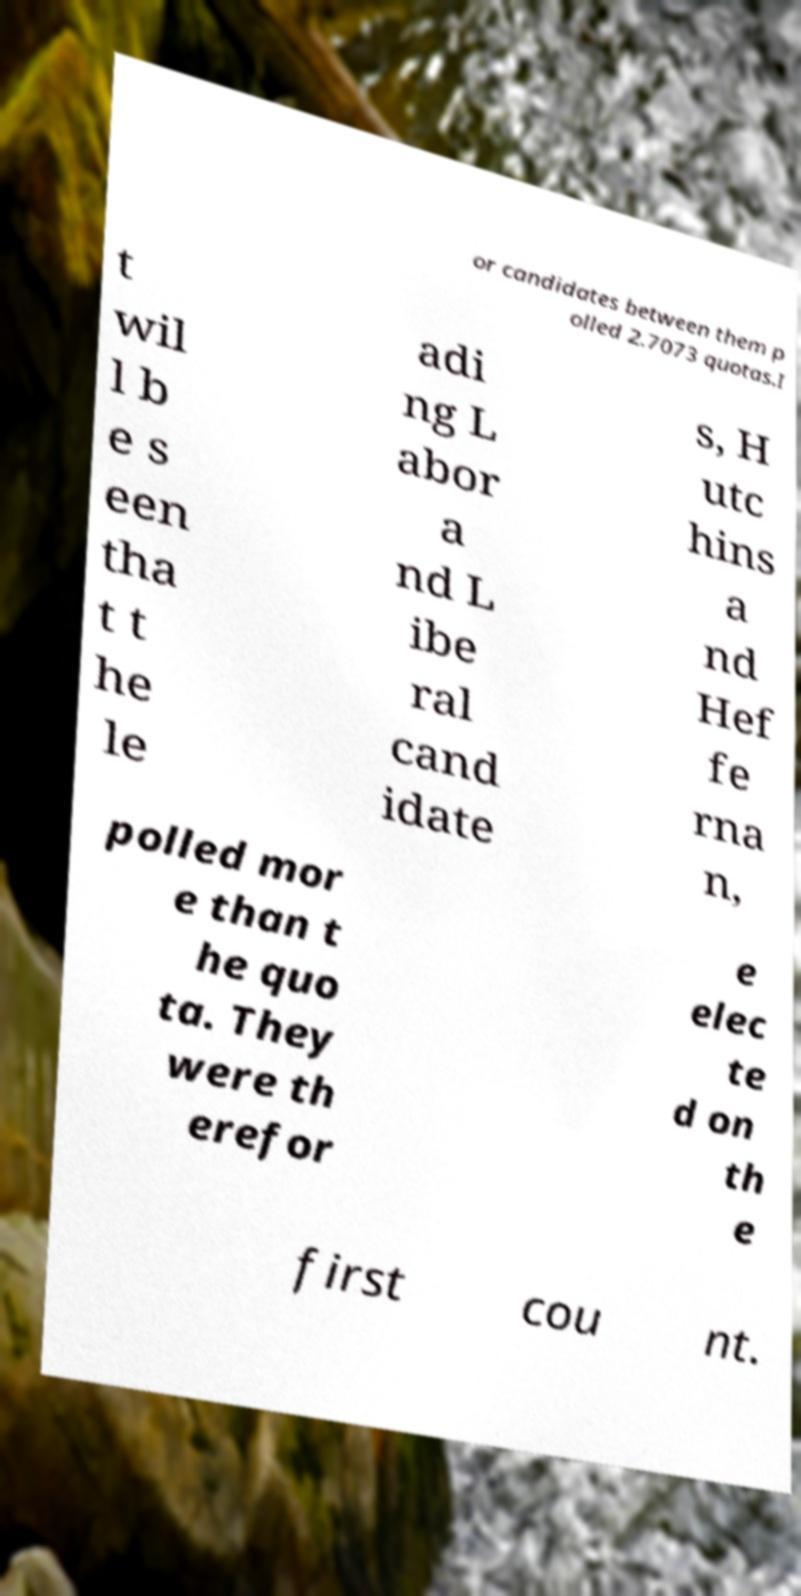Can you accurately transcribe the text from the provided image for me? or candidates between them p olled 2.7073 quotas.I t wil l b e s een tha t t he le adi ng L abor a nd L ibe ral cand idate s, H utc hins a nd Hef fe rna n, polled mor e than t he quo ta. They were th erefor e elec te d on th e first cou nt. 